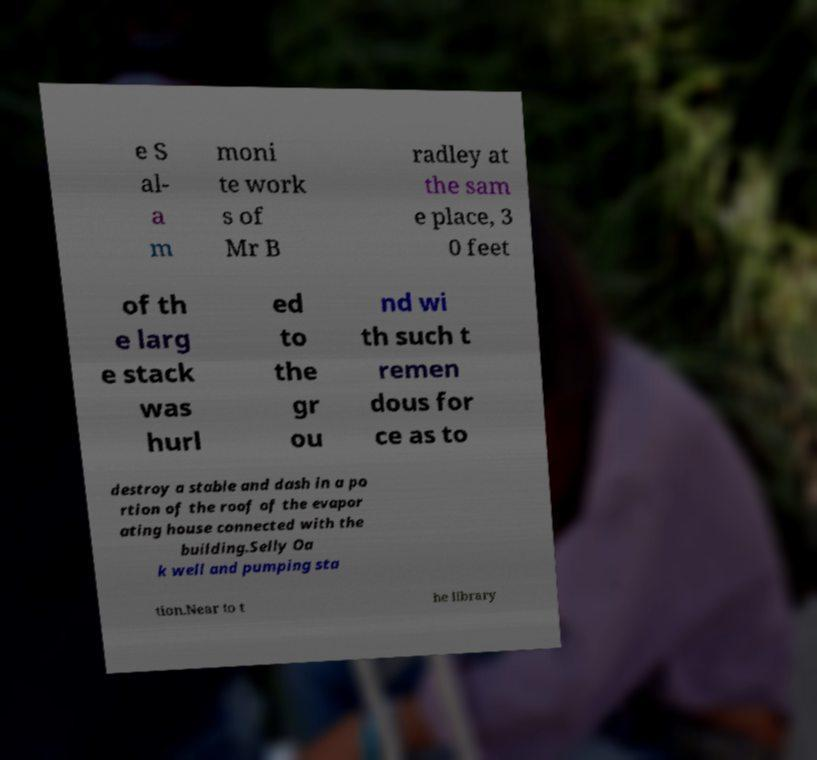I need the written content from this picture converted into text. Can you do that? e S al- a m moni te work s of Mr B radley at the sam e place, 3 0 feet of th e larg e stack was hurl ed to the gr ou nd wi th such t remen dous for ce as to destroy a stable and dash in a po rtion of the roof of the evapor ating house connected with the building.Selly Oa k well and pumping sta tion.Near to t he library 